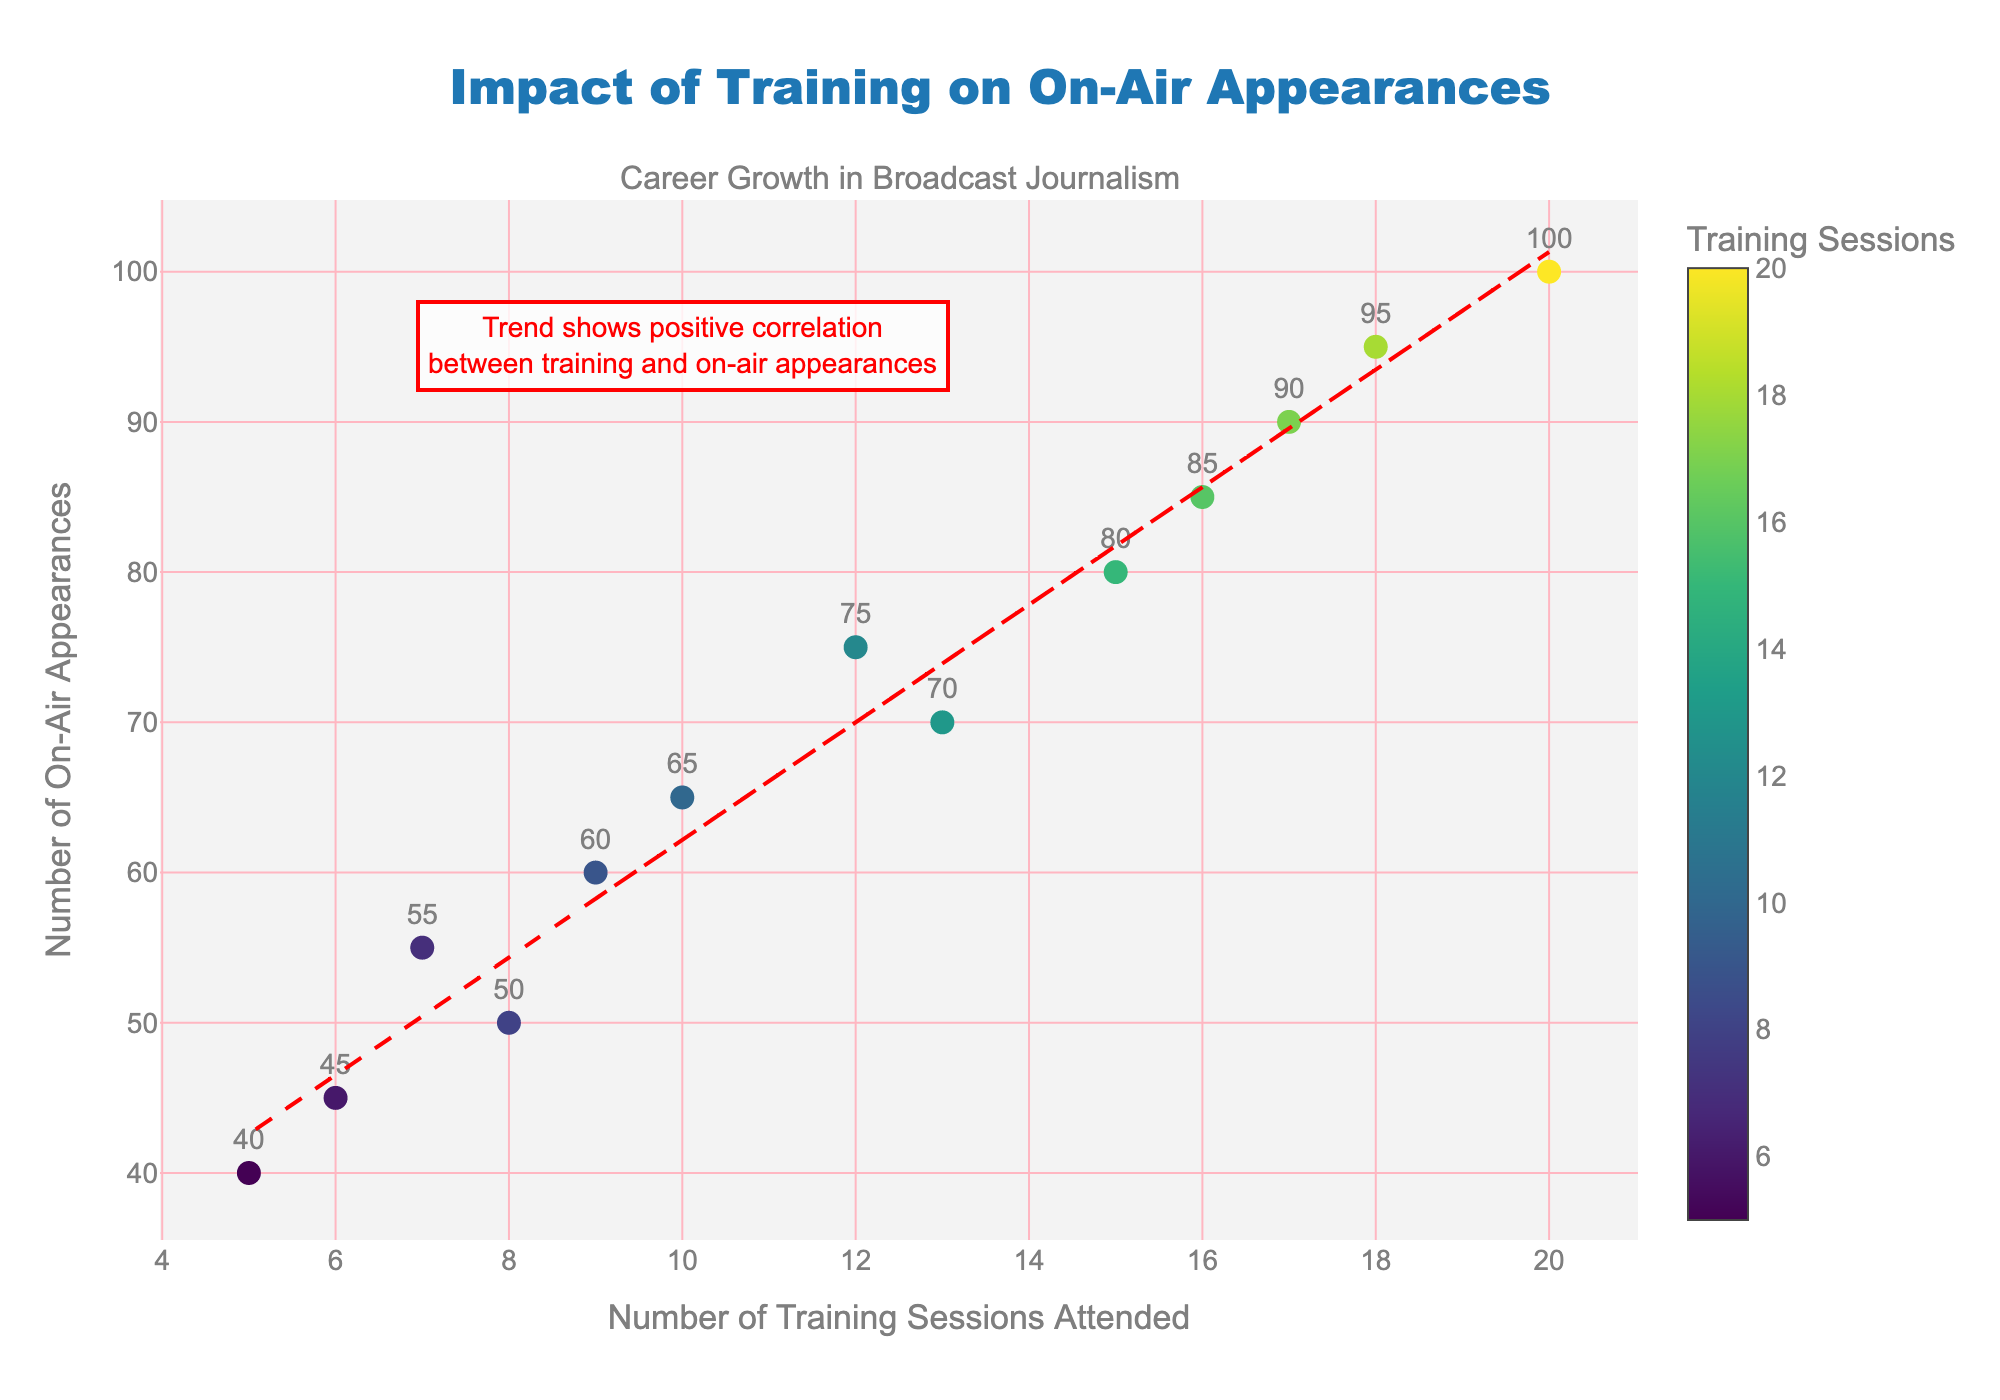What's the title of the scatter plot? The title of the plot is prominently displayed at the top center of the figure. Simply read the text that appears there to get the title.
Answer: Impact of Training on On-Air Appearances How many data points are shown in the scatter plot? Each dot on the scatter plot represents a data point. By counting the dots, we can determine the total number of data points.
Answer: 13 What is the color scale used for the markers based on? The color of each marker is determined by the number of training sessions attended. This is denoted by the colorbar on the right side of the plot.
Answer: Training Sessions Attended Which data point has the highest number of on-air appearances, and how many appearances is it? Look for the data point located highest on the y-axis and read its y-value. This point represents the highest number of on-air appearances.
Answer: 100 What are the x-axis and y-axis titles? The x-axis title can be found along the horizontal axis, and the y-axis title is along the vertical axis. Simply read the labels provided.
Answer: Number of Training Sessions Attended, Number of On-Air Appearances What is the average number of training sessions attended across all data points? Sum all the values of training sessions attended and divide by the total number of data points to find the average. \(\frac{8 + 12 + 10 + 15 + 5 + 17 + 7 + 20 + 13 + 16 + 6 + 18 + 9}{13} = \frac{156}{13}\)
Answer: 12 Is there a visible trend in the relationship between training sessions attended and on-air appearances? The plot includes a red dashed trend line that represents the general direction of the data. If this line slopes upwards, there is a positive relationship.
Answer: Yes, a positive trend How many on-air appearances would be predicted for someone who attended 10 training sessions according to the trend line? Locate where 10 training sessions are on the x-axis, trace upwards to the trend line, and then read the corresponding y-value.
Answer: Approximately 65 Compare the number of on-air appearances of the data points with 12 and 16 training sessions attended. Which one is higher and by how much? Identify the y-values for the data points with 12 and 16 training sessions attended, then subtract the smaller y-value from the larger one. 75 (for 12 sessions) and 85 (for 16 sessions), the difference is \(85 - 75\).
Answer: 16 sessions higher by 10 Annotating the explanation at the top right of the figure, what does it say about the correlation between training and on-air appearances? Read the annotation text included in a box on the figure, which provides an explanation of the trend indicated by the trend line.
Answer: Positive correlation between training and on-air appearances 